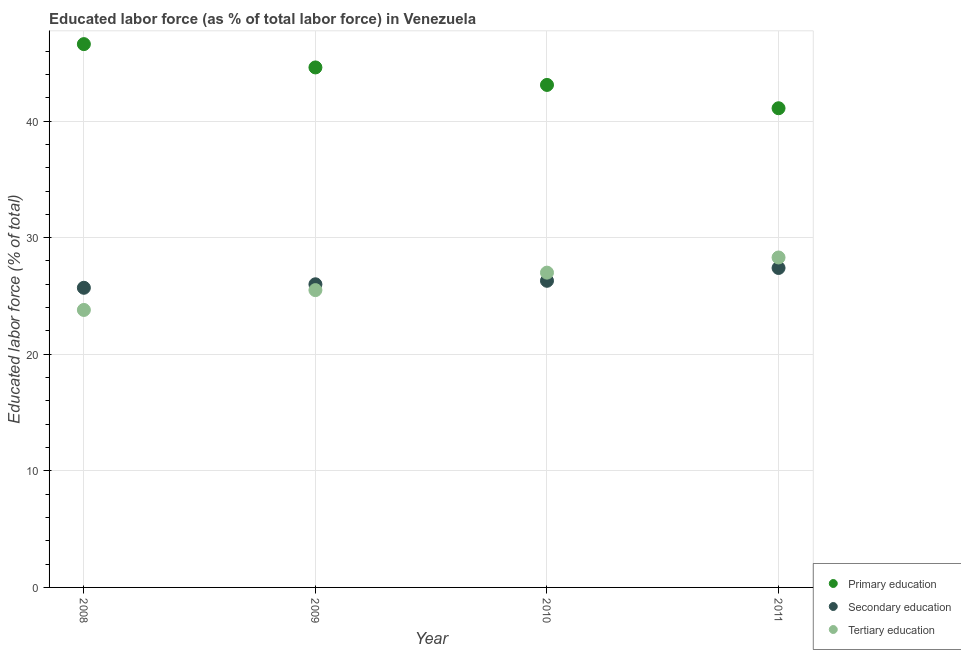How many different coloured dotlines are there?
Give a very brief answer. 3. Is the number of dotlines equal to the number of legend labels?
Offer a very short reply. Yes. What is the percentage of labor force who received primary education in 2010?
Give a very brief answer. 43.1. Across all years, what is the maximum percentage of labor force who received tertiary education?
Offer a very short reply. 28.3. Across all years, what is the minimum percentage of labor force who received primary education?
Provide a short and direct response. 41.1. In which year was the percentage of labor force who received primary education maximum?
Offer a terse response. 2008. In which year was the percentage of labor force who received primary education minimum?
Keep it short and to the point. 2011. What is the total percentage of labor force who received secondary education in the graph?
Your answer should be compact. 105.4. What is the difference between the percentage of labor force who received primary education in 2008 and that in 2010?
Offer a very short reply. 3.5. What is the difference between the percentage of labor force who received primary education in 2008 and the percentage of labor force who received secondary education in 2009?
Make the answer very short. 20.6. What is the average percentage of labor force who received tertiary education per year?
Your answer should be compact. 26.15. In the year 2010, what is the difference between the percentage of labor force who received primary education and percentage of labor force who received secondary education?
Make the answer very short. 16.8. What is the ratio of the percentage of labor force who received secondary education in 2008 to that in 2009?
Keep it short and to the point. 0.99. Is the percentage of labor force who received tertiary education in 2008 less than that in 2011?
Offer a terse response. Yes. What is the difference between the highest and the second highest percentage of labor force who received tertiary education?
Ensure brevity in your answer.  1.3. In how many years, is the percentage of labor force who received secondary education greater than the average percentage of labor force who received secondary education taken over all years?
Give a very brief answer. 1. How many dotlines are there?
Offer a terse response. 3. How many years are there in the graph?
Make the answer very short. 4. Are the values on the major ticks of Y-axis written in scientific E-notation?
Offer a terse response. No. Does the graph contain any zero values?
Give a very brief answer. No. Where does the legend appear in the graph?
Provide a short and direct response. Bottom right. How many legend labels are there?
Offer a terse response. 3. What is the title of the graph?
Your answer should be compact. Educated labor force (as % of total labor force) in Venezuela. What is the label or title of the Y-axis?
Keep it short and to the point. Educated labor force (% of total). What is the Educated labor force (% of total) of Primary education in 2008?
Offer a terse response. 46.6. What is the Educated labor force (% of total) in Secondary education in 2008?
Ensure brevity in your answer.  25.7. What is the Educated labor force (% of total) of Tertiary education in 2008?
Your answer should be very brief. 23.8. What is the Educated labor force (% of total) of Primary education in 2009?
Offer a very short reply. 44.6. What is the Educated labor force (% of total) in Tertiary education in 2009?
Your response must be concise. 25.5. What is the Educated labor force (% of total) in Primary education in 2010?
Provide a succinct answer. 43.1. What is the Educated labor force (% of total) of Secondary education in 2010?
Provide a succinct answer. 26.3. What is the Educated labor force (% of total) in Primary education in 2011?
Your response must be concise. 41.1. What is the Educated labor force (% of total) of Secondary education in 2011?
Your answer should be compact. 27.4. What is the Educated labor force (% of total) in Tertiary education in 2011?
Offer a very short reply. 28.3. Across all years, what is the maximum Educated labor force (% of total) of Primary education?
Keep it short and to the point. 46.6. Across all years, what is the maximum Educated labor force (% of total) of Secondary education?
Provide a short and direct response. 27.4. Across all years, what is the maximum Educated labor force (% of total) in Tertiary education?
Your answer should be very brief. 28.3. Across all years, what is the minimum Educated labor force (% of total) of Primary education?
Your answer should be compact. 41.1. Across all years, what is the minimum Educated labor force (% of total) in Secondary education?
Your answer should be very brief. 25.7. Across all years, what is the minimum Educated labor force (% of total) of Tertiary education?
Offer a terse response. 23.8. What is the total Educated labor force (% of total) of Primary education in the graph?
Give a very brief answer. 175.4. What is the total Educated labor force (% of total) of Secondary education in the graph?
Your answer should be very brief. 105.4. What is the total Educated labor force (% of total) of Tertiary education in the graph?
Give a very brief answer. 104.6. What is the difference between the Educated labor force (% of total) in Secondary education in 2008 and that in 2009?
Make the answer very short. -0.3. What is the difference between the Educated labor force (% of total) in Tertiary education in 2008 and that in 2009?
Ensure brevity in your answer.  -1.7. What is the difference between the Educated labor force (% of total) in Primary education in 2008 and that in 2010?
Make the answer very short. 3.5. What is the difference between the Educated labor force (% of total) of Primary education in 2008 and that in 2011?
Provide a succinct answer. 5.5. What is the difference between the Educated labor force (% of total) in Secondary education in 2008 and that in 2011?
Offer a very short reply. -1.7. What is the difference between the Educated labor force (% of total) in Tertiary education in 2008 and that in 2011?
Your answer should be very brief. -4.5. What is the difference between the Educated labor force (% of total) in Primary education in 2009 and that in 2010?
Your answer should be compact. 1.5. What is the difference between the Educated labor force (% of total) in Primary education in 2009 and that in 2011?
Give a very brief answer. 3.5. What is the difference between the Educated labor force (% of total) of Secondary education in 2009 and that in 2011?
Ensure brevity in your answer.  -1.4. What is the difference between the Educated labor force (% of total) of Tertiary education in 2009 and that in 2011?
Your answer should be compact. -2.8. What is the difference between the Educated labor force (% of total) in Primary education in 2010 and that in 2011?
Give a very brief answer. 2. What is the difference between the Educated labor force (% of total) in Secondary education in 2010 and that in 2011?
Offer a very short reply. -1.1. What is the difference between the Educated labor force (% of total) in Tertiary education in 2010 and that in 2011?
Make the answer very short. -1.3. What is the difference between the Educated labor force (% of total) in Primary education in 2008 and the Educated labor force (% of total) in Secondary education in 2009?
Offer a terse response. 20.6. What is the difference between the Educated labor force (% of total) in Primary education in 2008 and the Educated labor force (% of total) in Tertiary education in 2009?
Keep it short and to the point. 21.1. What is the difference between the Educated labor force (% of total) in Secondary education in 2008 and the Educated labor force (% of total) in Tertiary education in 2009?
Ensure brevity in your answer.  0.2. What is the difference between the Educated labor force (% of total) in Primary education in 2008 and the Educated labor force (% of total) in Secondary education in 2010?
Provide a short and direct response. 20.3. What is the difference between the Educated labor force (% of total) of Primary education in 2008 and the Educated labor force (% of total) of Tertiary education in 2010?
Ensure brevity in your answer.  19.6. What is the difference between the Educated labor force (% of total) in Primary education in 2008 and the Educated labor force (% of total) in Tertiary education in 2011?
Provide a succinct answer. 18.3. What is the difference between the Educated labor force (% of total) of Secondary education in 2008 and the Educated labor force (% of total) of Tertiary education in 2011?
Your answer should be very brief. -2.6. What is the difference between the Educated labor force (% of total) in Primary education in 2009 and the Educated labor force (% of total) in Secondary education in 2010?
Make the answer very short. 18.3. What is the difference between the Educated labor force (% of total) of Primary education in 2009 and the Educated labor force (% of total) of Tertiary education in 2010?
Ensure brevity in your answer.  17.6. What is the difference between the Educated labor force (% of total) in Secondary education in 2009 and the Educated labor force (% of total) in Tertiary education in 2010?
Your answer should be compact. -1. What is the difference between the Educated labor force (% of total) in Primary education in 2009 and the Educated labor force (% of total) in Secondary education in 2011?
Provide a succinct answer. 17.2. What is the difference between the Educated labor force (% of total) of Secondary education in 2010 and the Educated labor force (% of total) of Tertiary education in 2011?
Offer a terse response. -2. What is the average Educated labor force (% of total) of Primary education per year?
Offer a very short reply. 43.85. What is the average Educated labor force (% of total) in Secondary education per year?
Offer a terse response. 26.35. What is the average Educated labor force (% of total) in Tertiary education per year?
Your answer should be compact. 26.15. In the year 2008, what is the difference between the Educated labor force (% of total) in Primary education and Educated labor force (% of total) in Secondary education?
Keep it short and to the point. 20.9. In the year 2008, what is the difference between the Educated labor force (% of total) of Primary education and Educated labor force (% of total) of Tertiary education?
Offer a terse response. 22.8. In the year 2010, what is the difference between the Educated labor force (% of total) in Primary education and Educated labor force (% of total) in Tertiary education?
Provide a short and direct response. 16.1. What is the ratio of the Educated labor force (% of total) of Primary education in 2008 to that in 2009?
Offer a very short reply. 1.04. What is the ratio of the Educated labor force (% of total) in Tertiary education in 2008 to that in 2009?
Offer a terse response. 0.93. What is the ratio of the Educated labor force (% of total) in Primary education in 2008 to that in 2010?
Keep it short and to the point. 1.08. What is the ratio of the Educated labor force (% of total) of Secondary education in 2008 to that in 2010?
Your answer should be compact. 0.98. What is the ratio of the Educated labor force (% of total) of Tertiary education in 2008 to that in 2010?
Your answer should be compact. 0.88. What is the ratio of the Educated labor force (% of total) of Primary education in 2008 to that in 2011?
Offer a terse response. 1.13. What is the ratio of the Educated labor force (% of total) of Secondary education in 2008 to that in 2011?
Your response must be concise. 0.94. What is the ratio of the Educated labor force (% of total) of Tertiary education in 2008 to that in 2011?
Your answer should be very brief. 0.84. What is the ratio of the Educated labor force (% of total) of Primary education in 2009 to that in 2010?
Make the answer very short. 1.03. What is the ratio of the Educated labor force (% of total) of Secondary education in 2009 to that in 2010?
Keep it short and to the point. 0.99. What is the ratio of the Educated labor force (% of total) in Tertiary education in 2009 to that in 2010?
Give a very brief answer. 0.94. What is the ratio of the Educated labor force (% of total) of Primary education in 2009 to that in 2011?
Keep it short and to the point. 1.09. What is the ratio of the Educated labor force (% of total) of Secondary education in 2009 to that in 2011?
Give a very brief answer. 0.95. What is the ratio of the Educated labor force (% of total) of Tertiary education in 2009 to that in 2011?
Your answer should be compact. 0.9. What is the ratio of the Educated labor force (% of total) of Primary education in 2010 to that in 2011?
Your response must be concise. 1.05. What is the ratio of the Educated labor force (% of total) in Secondary education in 2010 to that in 2011?
Give a very brief answer. 0.96. What is the ratio of the Educated labor force (% of total) in Tertiary education in 2010 to that in 2011?
Offer a very short reply. 0.95. What is the difference between the highest and the lowest Educated labor force (% of total) in Primary education?
Offer a terse response. 5.5. What is the difference between the highest and the lowest Educated labor force (% of total) of Secondary education?
Give a very brief answer. 1.7. What is the difference between the highest and the lowest Educated labor force (% of total) in Tertiary education?
Provide a succinct answer. 4.5. 